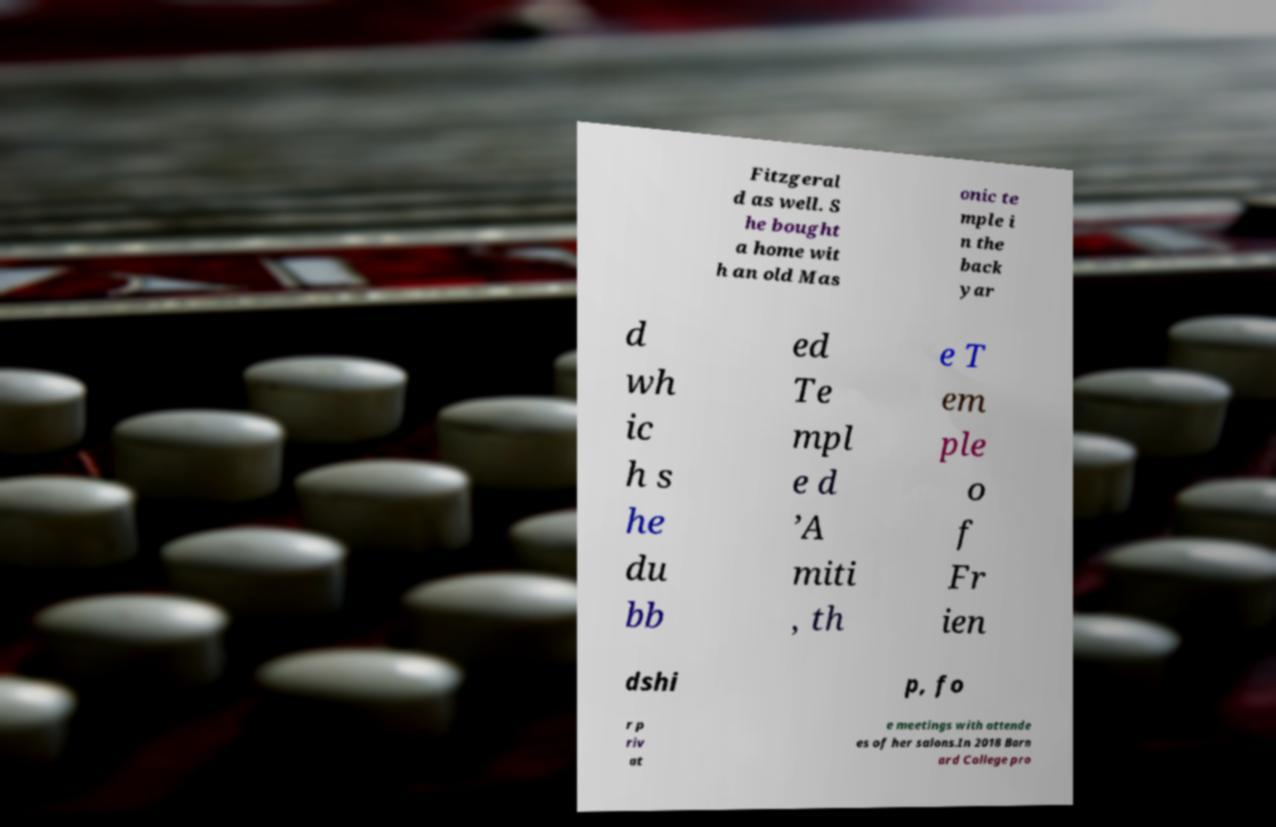Can you accurately transcribe the text from the provided image for me? Fitzgeral d as well. S he bought a home wit h an old Mas onic te mple i n the back yar d wh ic h s he du bb ed Te mpl e d ’A miti , th e T em ple o f Fr ien dshi p, fo r p riv at e meetings with attende es of her salons.In 2018 Barn ard College pro 